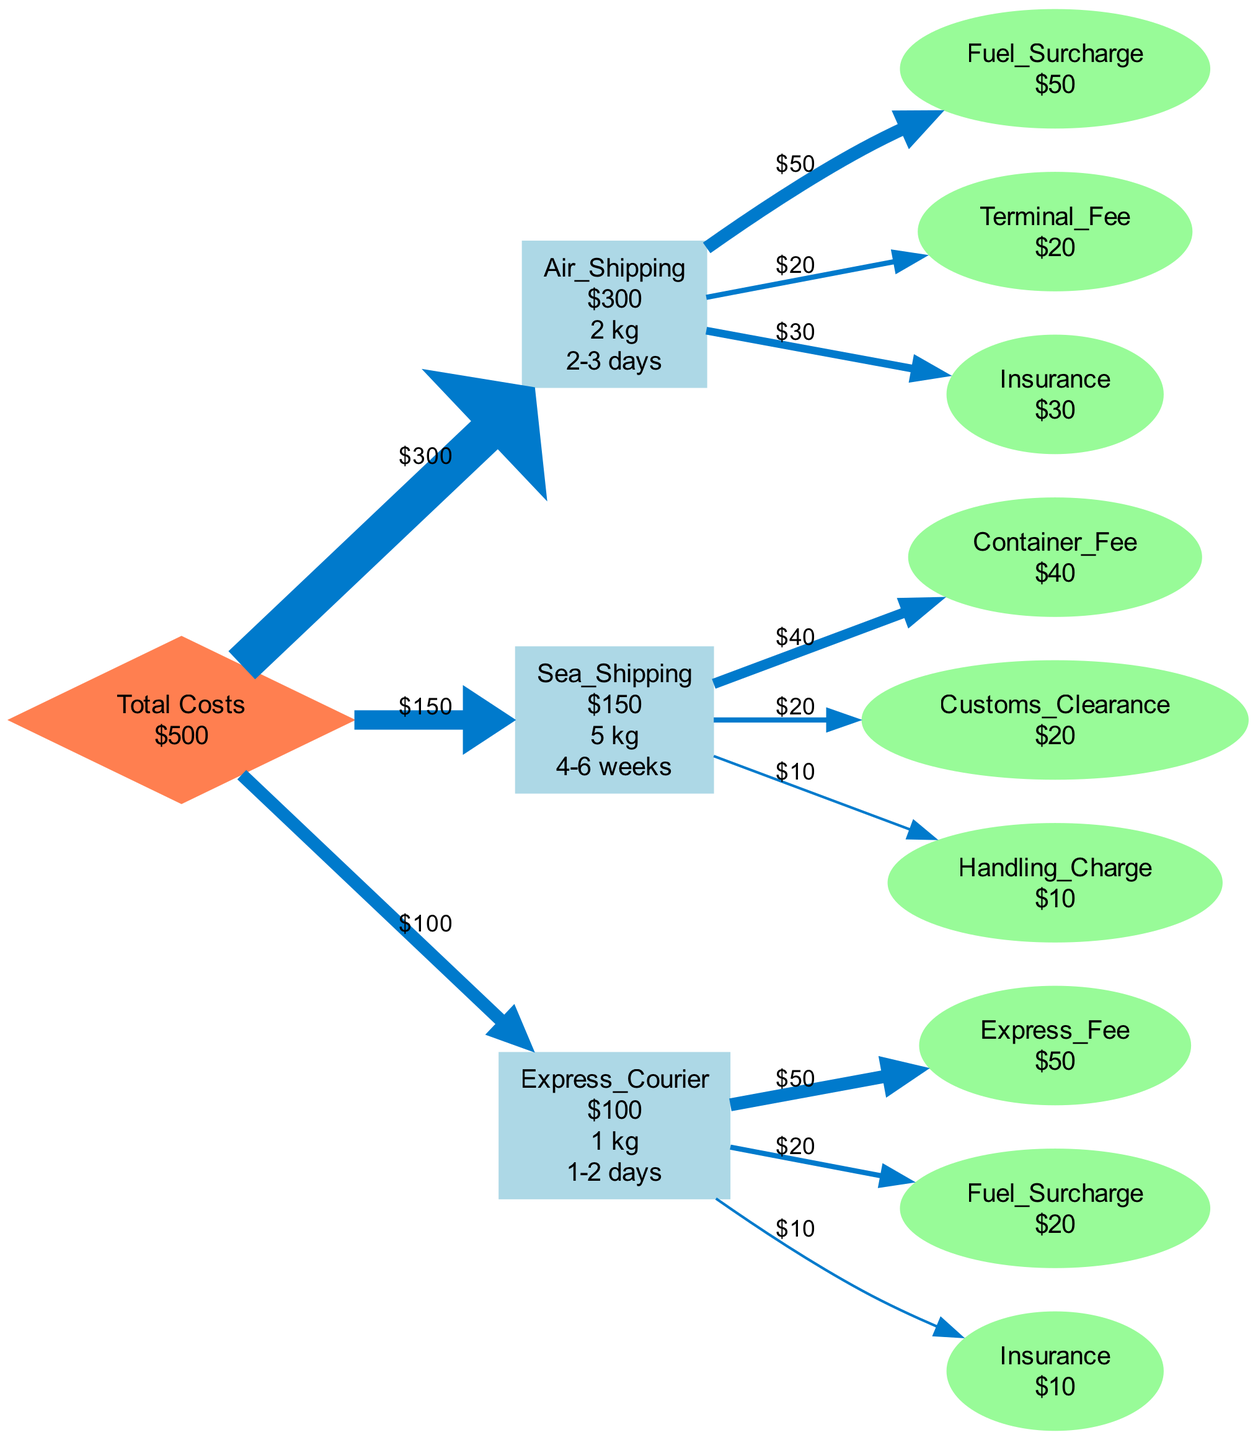What is the total shipping cost? The total shipping cost is indicated in the diamond node named "Total". The value shown is $500.
Answer: $500 Which shipment method has the highest cost? By examining the costs in the rectangle nodes for each shipping method, Air Shipping shows $300, which is higher than Sea Shipping ($150) and Express Courier ($100).
Answer: Air Shipping What is the delivery time for Sea Shipping? The delivery time for Sea Shipping is listed in the rectangle node associated with that method, which shows "4-6 weeks".
Answer: 4-6 weeks What is the sum of all details costs for Air Shipping? The details listed for Air Shipping are Fuel Surcharge ($50), Terminal Fee ($20), and Insurance ($30). Adding these gives $50 + $20 + $30 = $100.
Answer: $100 How many nodes represent shipping methods in total? The diagram includes one diamond node for total costs and three rectangle nodes representing different shipping methods (Air, Sea, Express). Counting these gives a total of 4 nodes.
Answer: 4 What is the cost of the Express Courier? The Express Courier's cost is shown in its corresponding rectangle node, which is $100.
Answer: $100 Which detail contributes the most to both the Air Shipping and Express Courier costs? For Air Shipping, the highest individual detail cost is the Fuel Surcharge at $50. For Express Courier, the Express Fee also stands out at $50. Thus, both share the highest contribution of $50.
Answer: $50 Which shipping method has the lowest weight? The weights of the shipping methods are listed as: Air Shipping (2 kg), Sea Shipping (5 kg), and Express Courier (1 kg). Therefore, Express Courier weighs the least at 1 kg.
Answer: 1 kg How much is the Customs Clearance fee in Sea Shipping? The Customs Clearance fee is detailed under Sea Shipping in the diagram, specifically noting a cost of $20.
Answer: $20 